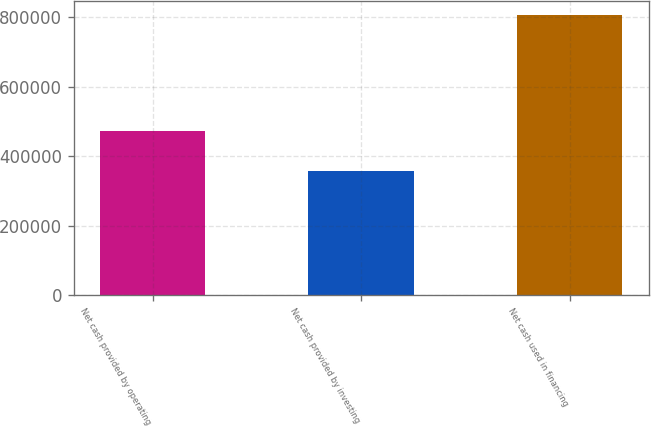Convert chart to OTSL. <chart><loc_0><loc_0><loc_500><loc_500><bar_chart><fcel>Net cash provided by operating<fcel>Net cash provided by investing<fcel>Net cash used in financing<nl><fcel>472249<fcel>356605<fcel>806702<nl></chart> 